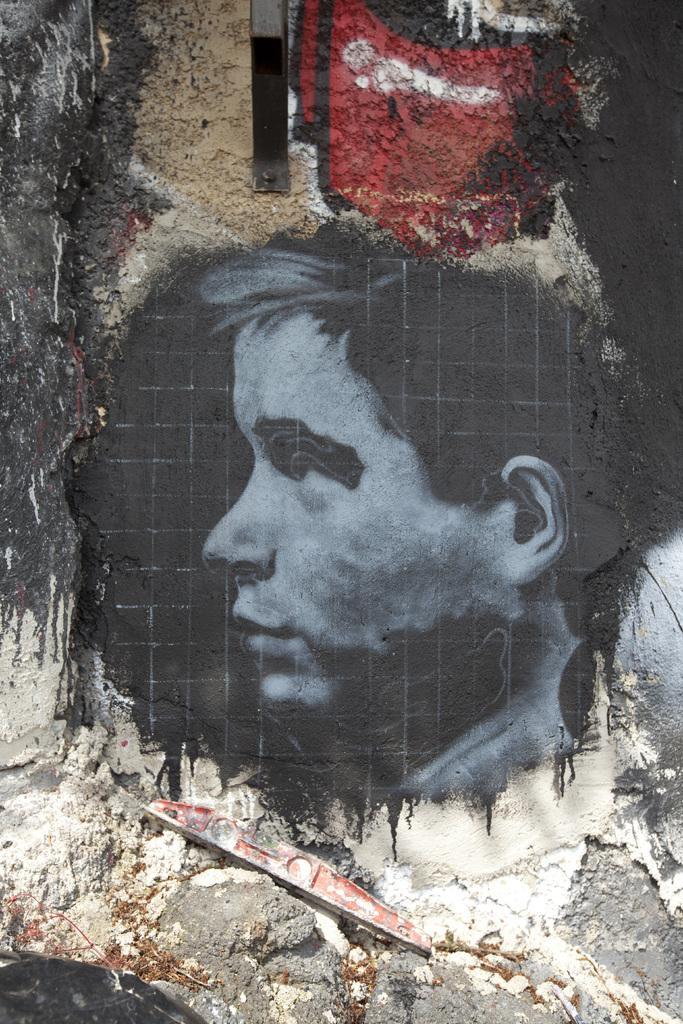How would you summarize this image in a sentence or two? In this image we can see a painting of the person's head. At the bottom of the image there is sand and an object. At the top of the image there is an object. 